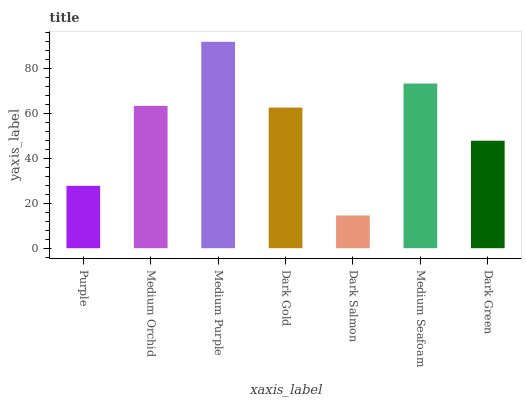Is Medium Orchid the minimum?
Answer yes or no. No. Is Medium Orchid the maximum?
Answer yes or no. No. Is Medium Orchid greater than Purple?
Answer yes or no. Yes. Is Purple less than Medium Orchid?
Answer yes or no. Yes. Is Purple greater than Medium Orchid?
Answer yes or no. No. Is Medium Orchid less than Purple?
Answer yes or no. No. Is Dark Gold the high median?
Answer yes or no. Yes. Is Dark Gold the low median?
Answer yes or no. Yes. Is Medium Orchid the high median?
Answer yes or no. No. Is Dark Salmon the low median?
Answer yes or no. No. 